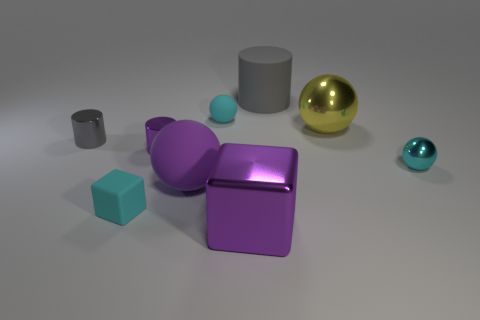Subtract all yellow spheres. How many spheres are left? 3 Subtract all blue cylinders. How many cyan spheres are left? 2 Add 1 yellow rubber cylinders. How many objects exist? 10 Subtract all yellow balls. How many balls are left? 3 Subtract all cylinders. How many objects are left? 6 Subtract 1 cylinders. How many cylinders are left? 2 Subtract all yellow blocks. Subtract all brown balls. How many blocks are left? 2 Subtract all big purple matte things. Subtract all gray cylinders. How many objects are left? 6 Add 6 big yellow shiny things. How many big yellow shiny things are left? 7 Add 1 purple cylinders. How many purple cylinders exist? 2 